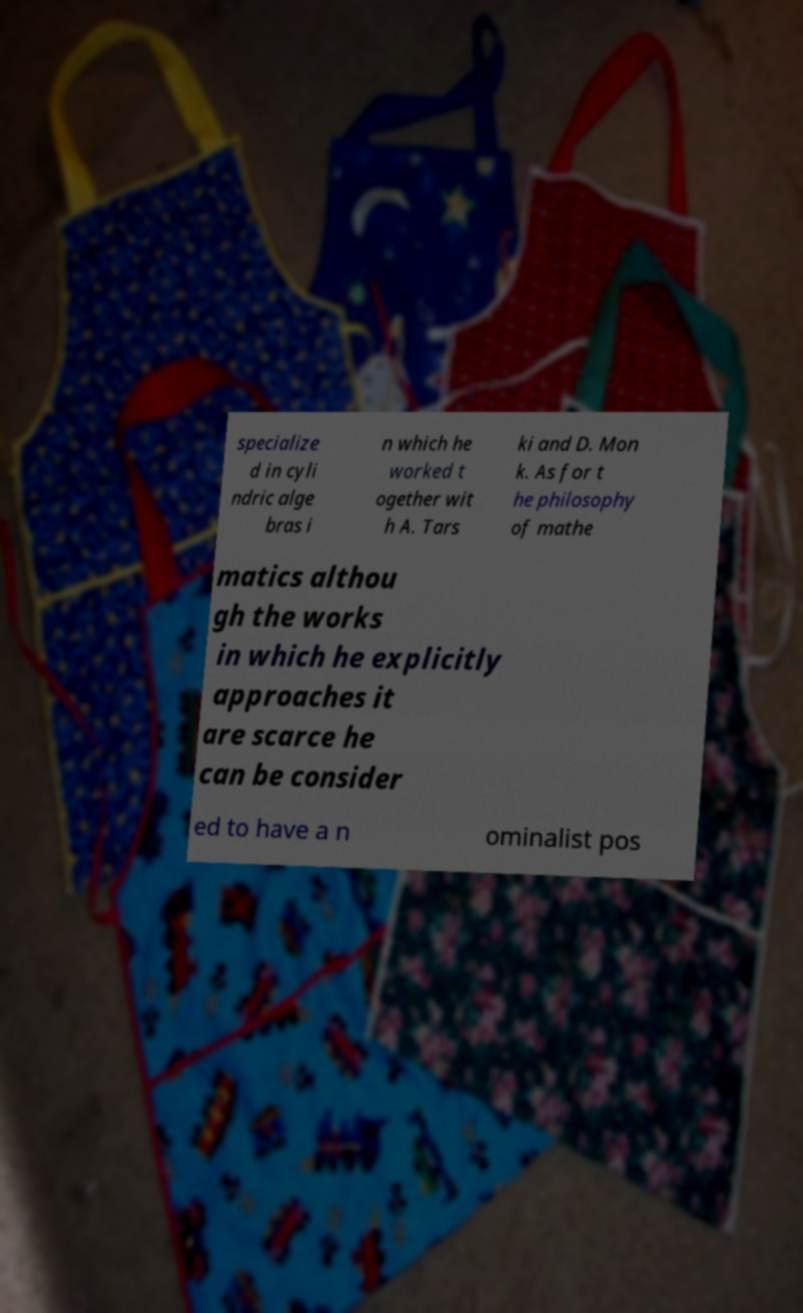Could you extract and type out the text from this image? specialize d in cyli ndric alge bras i n which he worked t ogether wit h A. Tars ki and D. Mon k. As for t he philosophy of mathe matics althou gh the works in which he explicitly approaches it are scarce he can be consider ed to have a n ominalist pos 